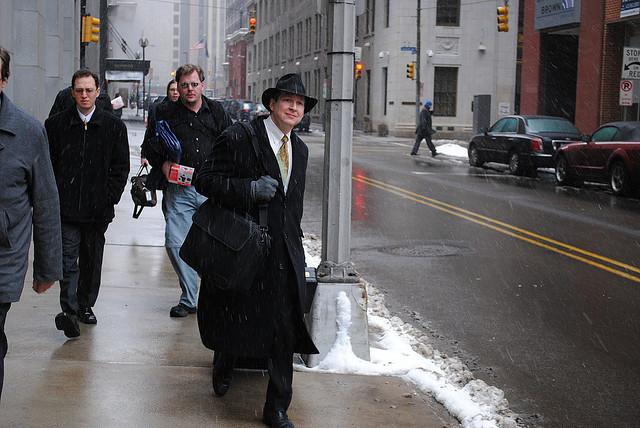What are the lines in the street for?
Answer briefly. Traffic. Who is dressed in a black coat?
Give a very brief answer. Man. Is it raining?
Concise answer only. Yes. 